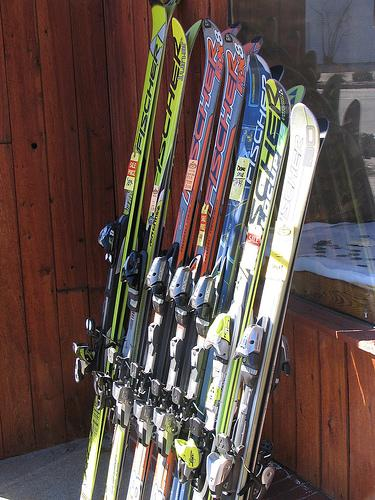Explain the environment surrounding the skis and the position of the skis in relation to the building. The skis are leaning against the side of a wooden building, with a window on the side, and a wooden ledge under the window. They are standing in front of the building's window. Count the number of skis in the image and mention a color associated with each set. There are seven sets of skis: green, red and blue, blue, green and yellow, white, yellow, and red. What is the primary sentiment conveyed by this image of skis leaning against a wooden building? The image conveys a sense of winter sports enthusiasm and retail display, inviting potential buyers to explore the skis and possibly purchase them. Describe the overall quality of the image in terms of composition, lighting, and clarity. The image has a balanced composition with skis at the center, well-lit with natural winter sunlight, and features clear details such as brand logos, bindings, and wood grain. Examine the objects around the skis and list any small details that add to the visual appeal of the image. The sale price tags, yellow stripe, wood grain, and small brown spot on the wood, light shining on the skis, and the colorful brand logos on various skis add to the visual appeal of the image. Describe the surface where the skis are placed and the type of store they are displayed in front of. The skis are placed on a grey carpet with a white dusting covering the walk area, and they are displayed in front of a store facade with a window and merchandise display. Analyze the object interaction between skis and their environment in terms of colors, textures, and reflections. The colorful skis contrast with the brown wood paneling and grey carpet while reflecting the surrounding trees, buildings, and merchandise in the store window, adding depth and visual interest. Identify the brand logo present on one of the skis and mention its color. Fischer is the brand logo written on one of the skis, and it is in red color. Infer the possible reason or event that might have inspired the arrangement of the skis in this image. The arrangement of the skis might be inspired by a seasonal sale or ski-related event, inviting customers to check out the variety of styles and colors available for purchase. Determine the potential purpose of the image in terms of marketing and advertisement. The purpose of the image might be to showcase the variety of skis available at a store, highlighting their brand, color, and design options, and ultimately enticing potential customers to visit the store and make a purchase. 